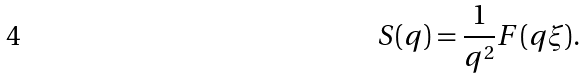<formula> <loc_0><loc_0><loc_500><loc_500>S ( q ) = \frac { 1 } { q ^ { 2 } } F ( q \xi ) .</formula> 